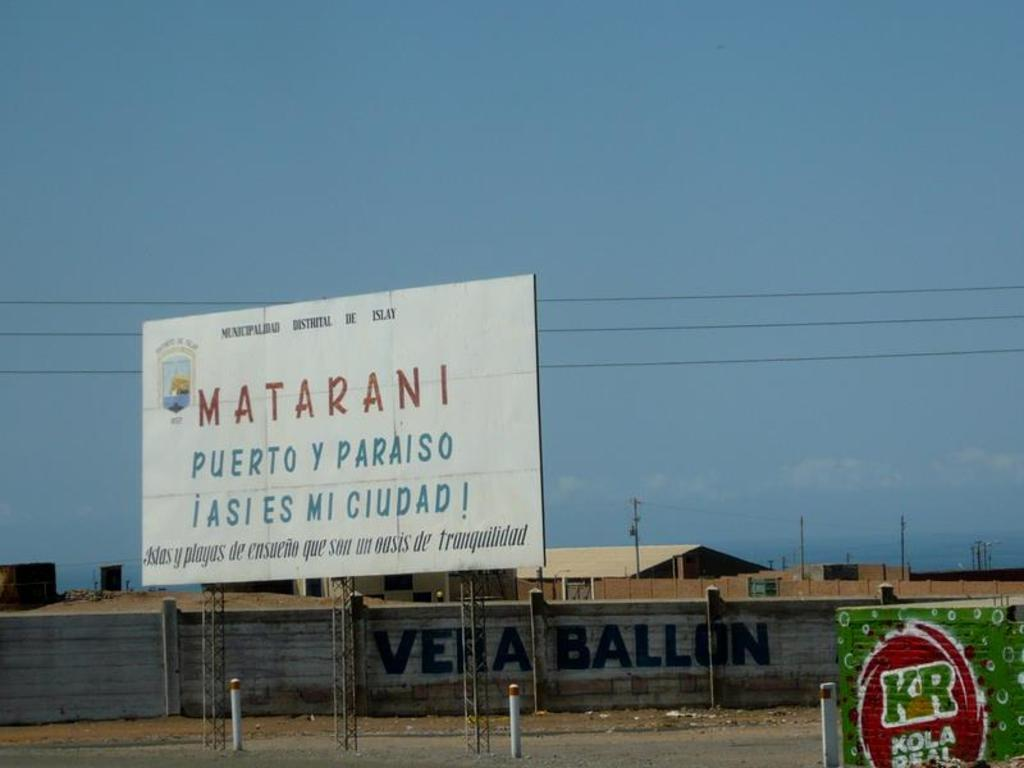<image>
Provide a brief description of the given image. A billboard advertising Matarani is on the side of the road 